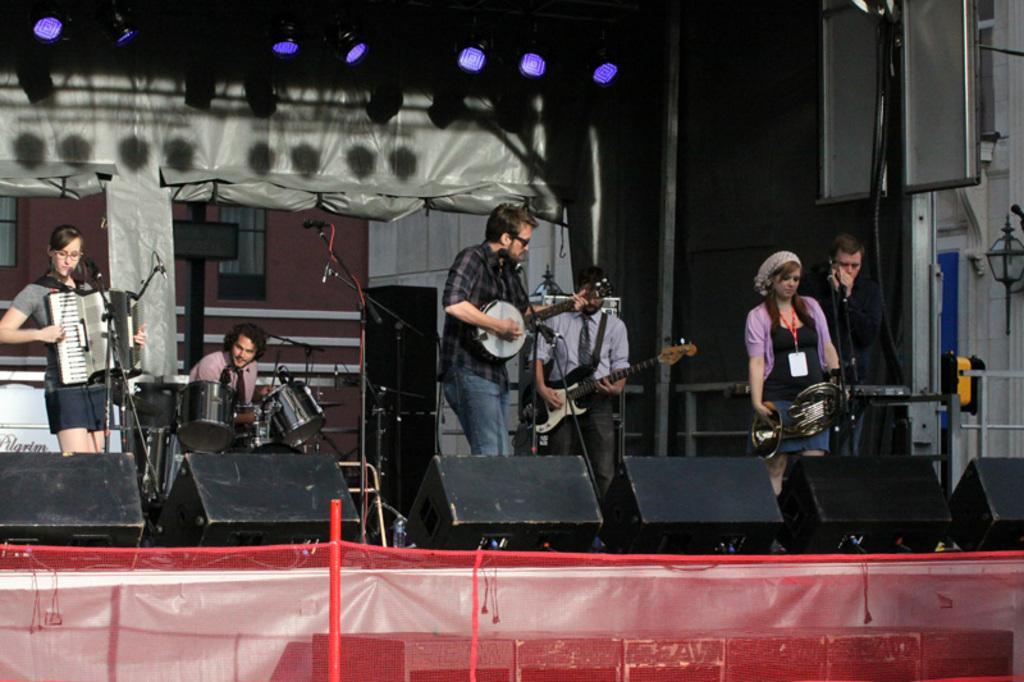How would you summarize this image in a sentence or two? As we can see in the image, there are few people playing different types of musical instruments. 